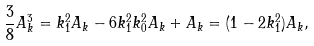<formula> <loc_0><loc_0><loc_500><loc_500>\frac { 3 } { 8 } A _ { k } ^ { 3 } = k _ { 1 } ^ { 2 } A _ { k } - 6 k _ { 1 } ^ { 2 } k _ { 0 } ^ { 2 } A _ { k } + A _ { k } = ( 1 - 2 k _ { 1 } ^ { 2 } ) A _ { k } ,</formula> 